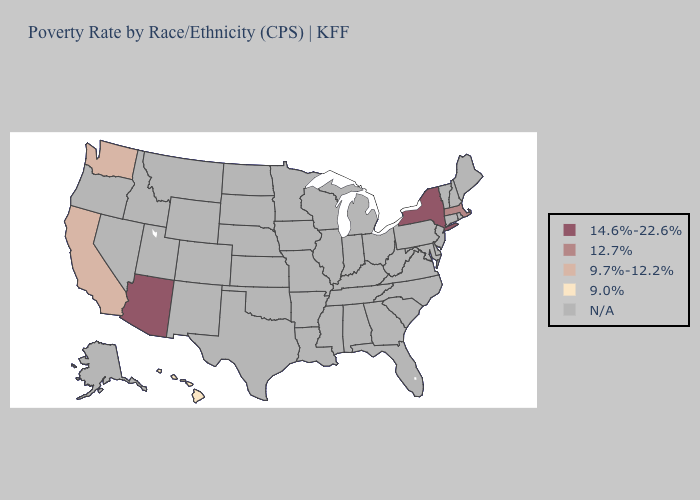Does the map have missing data?
Write a very short answer. Yes. What is the highest value in the USA?
Answer briefly. 14.6%-22.6%. Name the states that have a value in the range 12.7%?
Give a very brief answer. Massachusetts. Does Massachusetts have the highest value in the Northeast?
Keep it brief. No. Does New York have the highest value in the USA?
Keep it brief. Yes. Name the states that have a value in the range 9.7%-12.2%?
Answer briefly. California, Washington. What is the value of South Carolina?
Short answer required. N/A. Name the states that have a value in the range N/A?
Concise answer only. Alabama, Alaska, Arkansas, Colorado, Connecticut, Delaware, Florida, Georgia, Idaho, Illinois, Indiana, Iowa, Kansas, Kentucky, Louisiana, Maine, Maryland, Michigan, Minnesota, Mississippi, Missouri, Montana, Nebraska, Nevada, New Hampshire, New Jersey, New Mexico, North Carolina, North Dakota, Ohio, Oklahoma, Oregon, Pennsylvania, Rhode Island, South Carolina, South Dakota, Tennessee, Texas, Utah, Vermont, Virginia, West Virginia, Wisconsin, Wyoming. Which states have the lowest value in the Northeast?
Write a very short answer. Massachusetts. What is the value of Wisconsin?
Answer briefly. N/A. What is the value of Wisconsin?
Be succinct. N/A. 